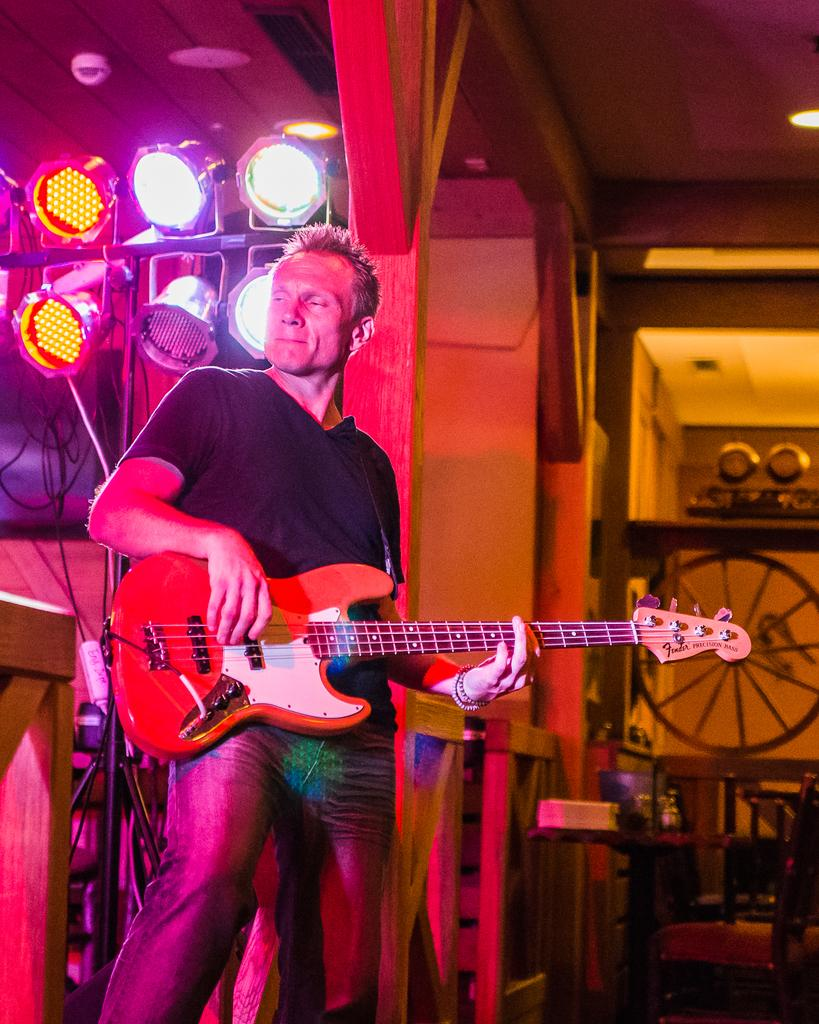Who is present in the image? There is a man in the image. What is the man doing in the image? The man is standing in the image. What object is the man holding in his hand? The man is holding a guitar in his hand. What can be seen in the background of the image? There are lights visible in the background of the image. What type of sleet is falling in the image? There is no mention of sleet in the image; it does not appear to be raining or snowing. 